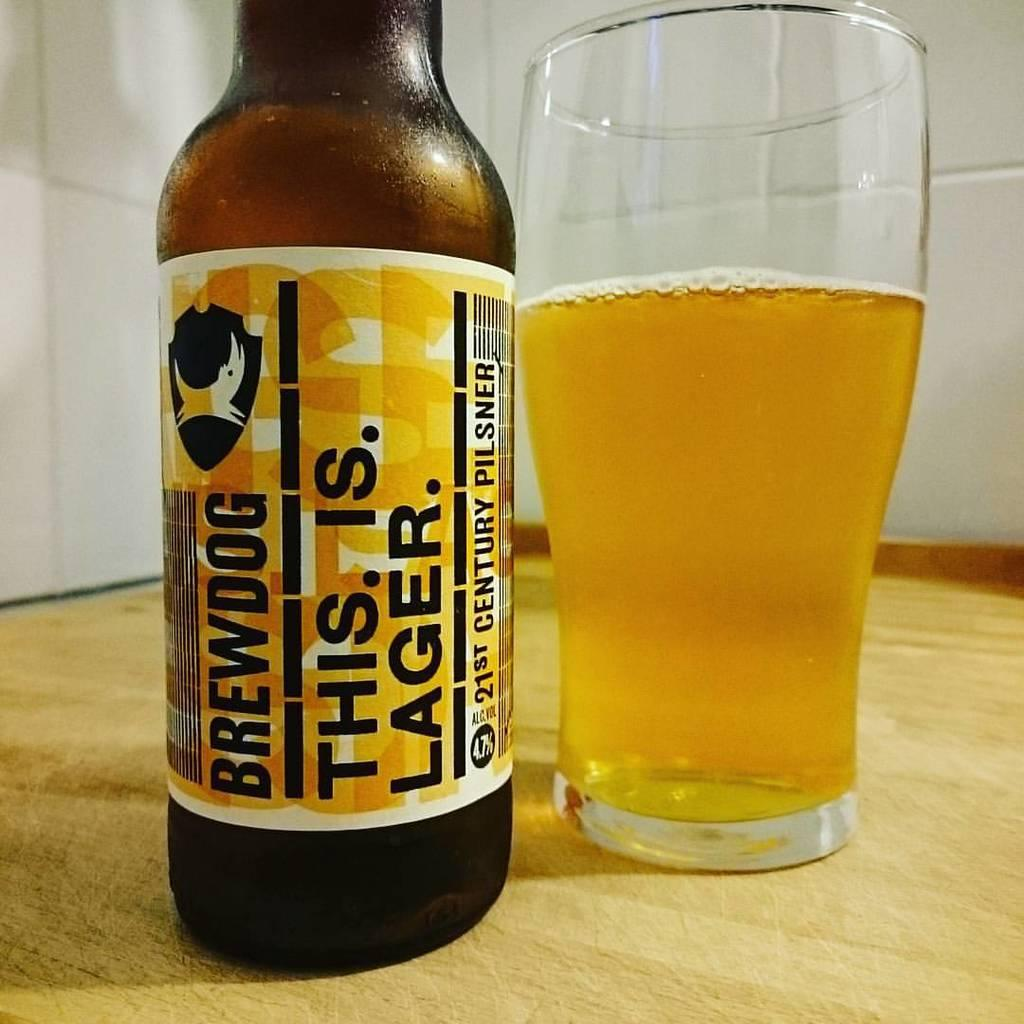<image>
Offer a succinct explanation of the picture presented. a glass filled with brewdog lagar. its slogan being this. is. lager 